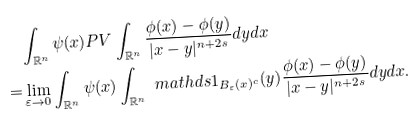<formula> <loc_0><loc_0><loc_500><loc_500>& \int _ { \mathbb { R } ^ { n } } \psi ( x ) P V \int _ { \mathbb { R } ^ { n } } \frac { \phi ( x ) - \phi ( y ) } { | x - y | ^ { n + 2 s } } d y d x \\ = & \lim _ { \varepsilon \to 0 } \int _ { \mathbb { R } ^ { n } } \psi ( x ) \int _ { \mathbb { R } ^ { n } } \ m a t h d s { 1 } _ { B _ { \varepsilon } ( x ) ^ { c } } ( y ) \frac { \phi ( x ) - \phi ( y ) } { | x - y | ^ { n + 2 s } } d y d x .</formula> 